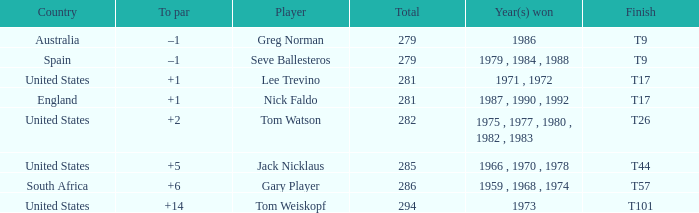Which player is from Australia? Greg Norman. 